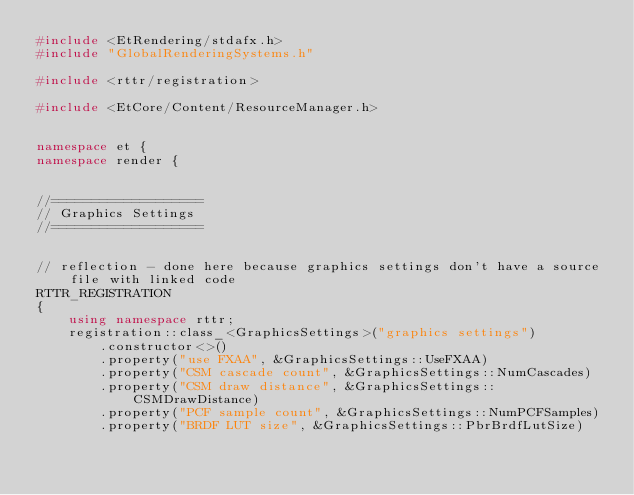Convert code to text. <code><loc_0><loc_0><loc_500><loc_500><_C++_>#include <EtRendering/stdafx.h>
#include "GlobalRenderingSystems.h"

#include <rttr/registration>

#include <EtCore/Content/ResourceManager.h>


namespace et {
namespace render {


//===================
// Graphics Settings
//===================


// reflection - done here because graphics settings don't have a source file with linked code
RTTR_REGISTRATION
{
	using namespace rttr;
	registration::class_<GraphicsSettings>("graphics settings")
		.constructor<>()
		.property("use FXAA", &GraphicsSettings::UseFXAA)
		.property("CSM cascade count", &GraphicsSettings::NumCascades)
		.property("CSM draw distance", &GraphicsSettings::CSMDrawDistance)
		.property("PCF sample count", &GraphicsSettings::NumPCFSamples)
		.property("BRDF LUT size", &GraphicsSettings::PbrBrdfLutSize)</code> 